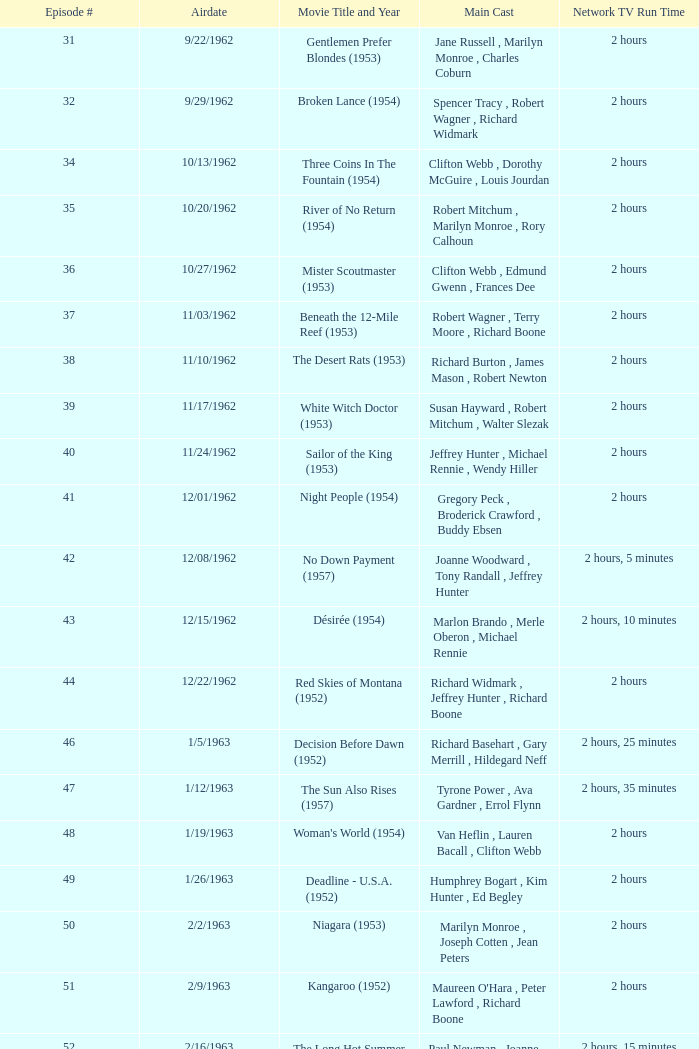What movie did dana wynter , mel ferrer , theodore bikel star in? Fraulein (1958). 